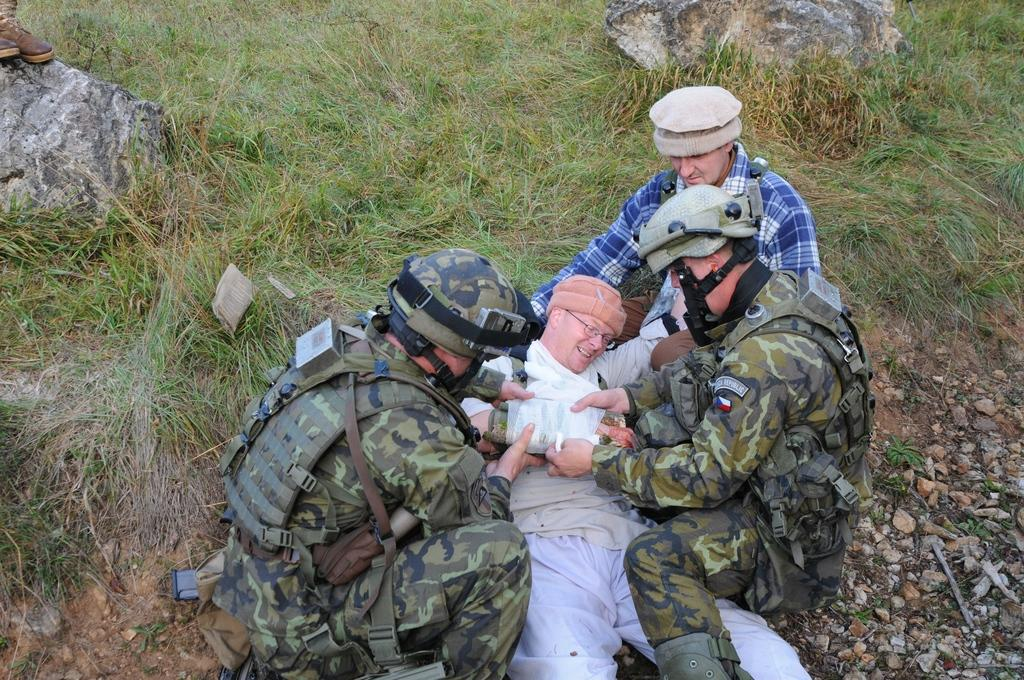Who or what is present in the image? There are people in the image. What type of terrain is visible in the image? There is grass and rocks in the image. How many balls can be seen in the image? There are no balls present in the image. What type of crow is sitting on the rocks in the image? There is no crow present in the image. 